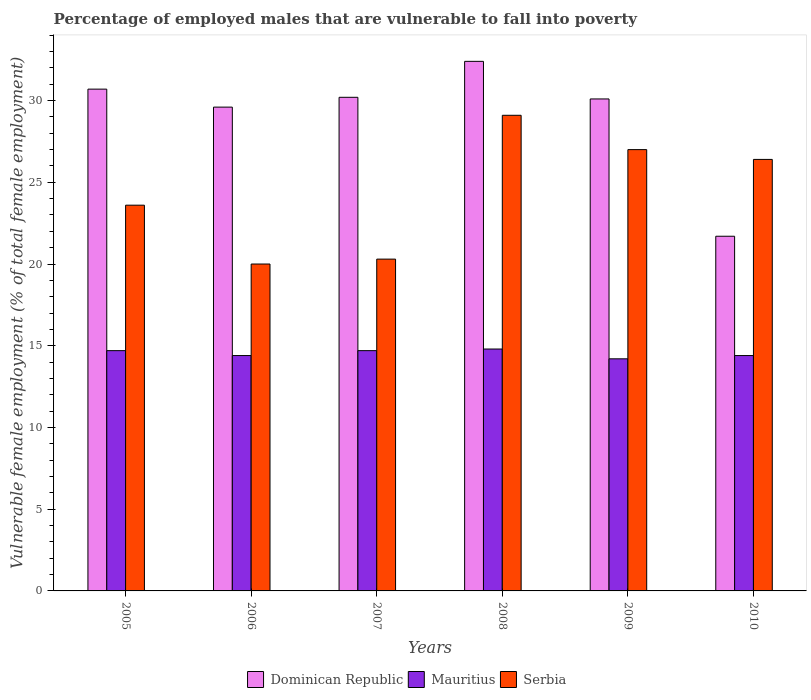How many groups of bars are there?
Provide a short and direct response. 6. Are the number of bars on each tick of the X-axis equal?
Give a very brief answer. Yes. How many bars are there on the 3rd tick from the right?
Give a very brief answer. 3. In how many cases, is the number of bars for a given year not equal to the number of legend labels?
Your answer should be compact. 0. What is the percentage of employed males who are vulnerable to fall into poverty in Mauritius in 2008?
Keep it short and to the point. 14.8. Across all years, what is the maximum percentage of employed males who are vulnerable to fall into poverty in Mauritius?
Provide a succinct answer. 14.8. Across all years, what is the minimum percentage of employed males who are vulnerable to fall into poverty in Mauritius?
Give a very brief answer. 14.2. What is the total percentage of employed males who are vulnerable to fall into poverty in Dominican Republic in the graph?
Keep it short and to the point. 174.7. What is the difference between the percentage of employed males who are vulnerable to fall into poverty in Mauritius in 2006 and that in 2008?
Offer a very short reply. -0.4. What is the difference between the percentage of employed males who are vulnerable to fall into poverty in Serbia in 2007 and the percentage of employed males who are vulnerable to fall into poverty in Mauritius in 2006?
Ensure brevity in your answer.  5.9. What is the average percentage of employed males who are vulnerable to fall into poverty in Dominican Republic per year?
Make the answer very short. 29.12. In the year 2008, what is the difference between the percentage of employed males who are vulnerable to fall into poverty in Serbia and percentage of employed males who are vulnerable to fall into poverty in Dominican Republic?
Your response must be concise. -3.3. In how many years, is the percentage of employed males who are vulnerable to fall into poverty in Mauritius greater than 2 %?
Keep it short and to the point. 6. What is the ratio of the percentage of employed males who are vulnerable to fall into poverty in Serbia in 2005 to that in 2008?
Offer a terse response. 0.81. What is the difference between the highest and the second highest percentage of employed males who are vulnerable to fall into poverty in Serbia?
Offer a very short reply. 2.1. What is the difference between the highest and the lowest percentage of employed males who are vulnerable to fall into poverty in Mauritius?
Provide a short and direct response. 0.6. What does the 1st bar from the left in 2008 represents?
Make the answer very short. Dominican Republic. What does the 3rd bar from the right in 2009 represents?
Your answer should be very brief. Dominican Republic. Is it the case that in every year, the sum of the percentage of employed males who are vulnerable to fall into poverty in Dominican Republic and percentage of employed males who are vulnerable to fall into poverty in Serbia is greater than the percentage of employed males who are vulnerable to fall into poverty in Mauritius?
Provide a short and direct response. Yes. How many bars are there?
Make the answer very short. 18. What is the difference between two consecutive major ticks on the Y-axis?
Offer a terse response. 5. Where does the legend appear in the graph?
Offer a terse response. Bottom center. How many legend labels are there?
Keep it short and to the point. 3. How are the legend labels stacked?
Your answer should be compact. Horizontal. What is the title of the graph?
Give a very brief answer. Percentage of employed males that are vulnerable to fall into poverty. Does "India" appear as one of the legend labels in the graph?
Give a very brief answer. No. What is the label or title of the Y-axis?
Your answer should be very brief. Vulnerable female employment (% of total female employment). What is the Vulnerable female employment (% of total female employment) of Dominican Republic in 2005?
Give a very brief answer. 30.7. What is the Vulnerable female employment (% of total female employment) of Mauritius in 2005?
Keep it short and to the point. 14.7. What is the Vulnerable female employment (% of total female employment) of Serbia in 2005?
Your response must be concise. 23.6. What is the Vulnerable female employment (% of total female employment) of Dominican Republic in 2006?
Your answer should be very brief. 29.6. What is the Vulnerable female employment (% of total female employment) of Mauritius in 2006?
Ensure brevity in your answer.  14.4. What is the Vulnerable female employment (% of total female employment) of Serbia in 2006?
Provide a short and direct response. 20. What is the Vulnerable female employment (% of total female employment) of Dominican Republic in 2007?
Provide a succinct answer. 30.2. What is the Vulnerable female employment (% of total female employment) of Mauritius in 2007?
Your answer should be compact. 14.7. What is the Vulnerable female employment (% of total female employment) in Serbia in 2007?
Your answer should be compact. 20.3. What is the Vulnerable female employment (% of total female employment) in Dominican Republic in 2008?
Provide a succinct answer. 32.4. What is the Vulnerable female employment (% of total female employment) of Mauritius in 2008?
Provide a succinct answer. 14.8. What is the Vulnerable female employment (% of total female employment) of Serbia in 2008?
Your response must be concise. 29.1. What is the Vulnerable female employment (% of total female employment) in Dominican Republic in 2009?
Your answer should be very brief. 30.1. What is the Vulnerable female employment (% of total female employment) of Mauritius in 2009?
Offer a terse response. 14.2. What is the Vulnerable female employment (% of total female employment) in Dominican Republic in 2010?
Provide a succinct answer. 21.7. What is the Vulnerable female employment (% of total female employment) in Mauritius in 2010?
Give a very brief answer. 14.4. What is the Vulnerable female employment (% of total female employment) in Serbia in 2010?
Ensure brevity in your answer.  26.4. Across all years, what is the maximum Vulnerable female employment (% of total female employment) of Dominican Republic?
Ensure brevity in your answer.  32.4. Across all years, what is the maximum Vulnerable female employment (% of total female employment) of Mauritius?
Ensure brevity in your answer.  14.8. Across all years, what is the maximum Vulnerable female employment (% of total female employment) in Serbia?
Your answer should be very brief. 29.1. Across all years, what is the minimum Vulnerable female employment (% of total female employment) in Dominican Republic?
Your answer should be very brief. 21.7. Across all years, what is the minimum Vulnerable female employment (% of total female employment) of Mauritius?
Provide a succinct answer. 14.2. Across all years, what is the minimum Vulnerable female employment (% of total female employment) of Serbia?
Make the answer very short. 20. What is the total Vulnerable female employment (% of total female employment) of Dominican Republic in the graph?
Your answer should be very brief. 174.7. What is the total Vulnerable female employment (% of total female employment) of Mauritius in the graph?
Your answer should be compact. 87.2. What is the total Vulnerable female employment (% of total female employment) of Serbia in the graph?
Ensure brevity in your answer.  146.4. What is the difference between the Vulnerable female employment (% of total female employment) in Mauritius in 2005 and that in 2006?
Offer a terse response. 0.3. What is the difference between the Vulnerable female employment (% of total female employment) of Mauritius in 2005 and that in 2007?
Provide a short and direct response. 0. What is the difference between the Vulnerable female employment (% of total female employment) in Serbia in 2005 and that in 2007?
Your response must be concise. 3.3. What is the difference between the Vulnerable female employment (% of total female employment) in Serbia in 2005 and that in 2008?
Make the answer very short. -5.5. What is the difference between the Vulnerable female employment (% of total female employment) of Dominican Republic in 2005 and that in 2009?
Ensure brevity in your answer.  0.6. What is the difference between the Vulnerable female employment (% of total female employment) of Dominican Republic in 2005 and that in 2010?
Offer a terse response. 9. What is the difference between the Vulnerable female employment (% of total female employment) of Mauritius in 2005 and that in 2010?
Give a very brief answer. 0.3. What is the difference between the Vulnerable female employment (% of total female employment) in Serbia in 2005 and that in 2010?
Your answer should be compact. -2.8. What is the difference between the Vulnerable female employment (% of total female employment) of Mauritius in 2006 and that in 2008?
Your answer should be very brief. -0.4. What is the difference between the Vulnerable female employment (% of total female employment) of Dominican Republic in 2006 and that in 2009?
Keep it short and to the point. -0.5. What is the difference between the Vulnerable female employment (% of total female employment) of Mauritius in 2006 and that in 2009?
Offer a terse response. 0.2. What is the difference between the Vulnerable female employment (% of total female employment) of Serbia in 2006 and that in 2009?
Provide a succinct answer. -7. What is the difference between the Vulnerable female employment (% of total female employment) in Dominican Republic in 2006 and that in 2010?
Provide a short and direct response. 7.9. What is the difference between the Vulnerable female employment (% of total female employment) of Mauritius in 2006 and that in 2010?
Your answer should be very brief. 0. What is the difference between the Vulnerable female employment (% of total female employment) in Serbia in 2006 and that in 2010?
Make the answer very short. -6.4. What is the difference between the Vulnerable female employment (% of total female employment) of Dominican Republic in 2007 and that in 2009?
Offer a very short reply. 0.1. What is the difference between the Vulnerable female employment (% of total female employment) in Serbia in 2007 and that in 2009?
Ensure brevity in your answer.  -6.7. What is the difference between the Vulnerable female employment (% of total female employment) of Dominican Republic in 2007 and that in 2010?
Keep it short and to the point. 8.5. What is the difference between the Vulnerable female employment (% of total female employment) in Serbia in 2007 and that in 2010?
Offer a very short reply. -6.1. What is the difference between the Vulnerable female employment (% of total female employment) of Dominican Republic in 2008 and that in 2009?
Provide a short and direct response. 2.3. What is the difference between the Vulnerable female employment (% of total female employment) in Dominican Republic in 2005 and the Vulnerable female employment (% of total female employment) in Serbia in 2006?
Offer a very short reply. 10.7. What is the difference between the Vulnerable female employment (% of total female employment) in Dominican Republic in 2005 and the Vulnerable female employment (% of total female employment) in Mauritius in 2007?
Your answer should be compact. 16. What is the difference between the Vulnerable female employment (% of total female employment) of Dominican Republic in 2005 and the Vulnerable female employment (% of total female employment) of Mauritius in 2008?
Offer a terse response. 15.9. What is the difference between the Vulnerable female employment (% of total female employment) of Mauritius in 2005 and the Vulnerable female employment (% of total female employment) of Serbia in 2008?
Offer a terse response. -14.4. What is the difference between the Vulnerable female employment (% of total female employment) in Mauritius in 2005 and the Vulnerable female employment (% of total female employment) in Serbia in 2009?
Offer a terse response. -12.3. What is the difference between the Vulnerable female employment (% of total female employment) in Dominican Republic in 2005 and the Vulnerable female employment (% of total female employment) in Mauritius in 2010?
Give a very brief answer. 16.3. What is the difference between the Vulnerable female employment (% of total female employment) of Mauritius in 2005 and the Vulnerable female employment (% of total female employment) of Serbia in 2010?
Offer a terse response. -11.7. What is the difference between the Vulnerable female employment (% of total female employment) in Dominican Republic in 2006 and the Vulnerable female employment (% of total female employment) in Mauritius in 2007?
Provide a succinct answer. 14.9. What is the difference between the Vulnerable female employment (% of total female employment) of Dominican Republic in 2006 and the Vulnerable female employment (% of total female employment) of Serbia in 2007?
Provide a succinct answer. 9.3. What is the difference between the Vulnerable female employment (% of total female employment) of Dominican Republic in 2006 and the Vulnerable female employment (% of total female employment) of Serbia in 2008?
Your response must be concise. 0.5. What is the difference between the Vulnerable female employment (% of total female employment) of Mauritius in 2006 and the Vulnerable female employment (% of total female employment) of Serbia in 2008?
Provide a succinct answer. -14.7. What is the difference between the Vulnerable female employment (% of total female employment) in Dominican Republic in 2006 and the Vulnerable female employment (% of total female employment) in Serbia in 2009?
Your answer should be very brief. 2.6. What is the difference between the Vulnerable female employment (% of total female employment) of Dominican Republic in 2006 and the Vulnerable female employment (% of total female employment) of Serbia in 2010?
Your answer should be compact. 3.2. What is the difference between the Vulnerable female employment (% of total female employment) of Mauritius in 2006 and the Vulnerable female employment (% of total female employment) of Serbia in 2010?
Your answer should be compact. -12. What is the difference between the Vulnerable female employment (% of total female employment) of Dominican Republic in 2007 and the Vulnerable female employment (% of total female employment) of Mauritius in 2008?
Your answer should be compact. 15.4. What is the difference between the Vulnerable female employment (% of total female employment) in Dominican Republic in 2007 and the Vulnerable female employment (% of total female employment) in Serbia in 2008?
Ensure brevity in your answer.  1.1. What is the difference between the Vulnerable female employment (% of total female employment) of Mauritius in 2007 and the Vulnerable female employment (% of total female employment) of Serbia in 2008?
Ensure brevity in your answer.  -14.4. What is the difference between the Vulnerable female employment (% of total female employment) in Dominican Republic in 2007 and the Vulnerable female employment (% of total female employment) in Mauritius in 2009?
Your answer should be compact. 16. What is the difference between the Vulnerable female employment (% of total female employment) of Dominican Republic in 2007 and the Vulnerable female employment (% of total female employment) of Serbia in 2009?
Offer a very short reply. 3.2. What is the difference between the Vulnerable female employment (% of total female employment) of Mauritius in 2007 and the Vulnerable female employment (% of total female employment) of Serbia in 2009?
Your answer should be compact. -12.3. What is the difference between the Vulnerable female employment (% of total female employment) in Dominican Republic in 2008 and the Vulnerable female employment (% of total female employment) in Mauritius in 2009?
Your answer should be very brief. 18.2. What is the difference between the Vulnerable female employment (% of total female employment) of Mauritius in 2008 and the Vulnerable female employment (% of total female employment) of Serbia in 2009?
Provide a short and direct response. -12.2. What is the difference between the Vulnerable female employment (% of total female employment) of Dominican Republic in 2008 and the Vulnerable female employment (% of total female employment) of Serbia in 2010?
Offer a terse response. 6. What is the difference between the Vulnerable female employment (% of total female employment) of Mauritius in 2008 and the Vulnerable female employment (% of total female employment) of Serbia in 2010?
Keep it short and to the point. -11.6. What is the difference between the Vulnerable female employment (% of total female employment) of Dominican Republic in 2009 and the Vulnerable female employment (% of total female employment) of Mauritius in 2010?
Keep it short and to the point. 15.7. What is the difference between the Vulnerable female employment (% of total female employment) of Dominican Republic in 2009 and the Vulnerable female employment (% of total female employment) of Serbia in 2010?
Offer a very short reply. 3.7. What is the average Vulnerable female employment (% of total female employment) in Dominican Republic per year?
Ensure brevity in your answer.  29.12. What is the average Vulnerable female employment (% of total female employment) in Mauritius per year?
Keep it short and to the point. 14.53. What is the average Vulnerable female employment (% of total female employment) of Serbia per year?
Your answer should be compact. 24.4. In the year 2005, what is the difference between the Vulnerable female employment (% of total female employment) of Dominican Republic and Vulnerable female employment (% of total female employment) of Mauritius?
Your answer should be compact. 16. In the year 2005, what is the difference between the Vulnerable female employment (% of total female employment) in Dominican Republic and Vulnerable female employment (% of total female employment) in Serbia?
Offer a terse response. 7.1. In the year 2006, what is the difference between the Vulnerable female employment (% of total female employment) of Dominican Republic and Vulnerable female employment (% of total female employment) of Serbia?
Offer a very short reply. 9.6. In the year 2007, what is the difference between the Vulnerable female employment (% of total female employment) in Dominican Republic and Vulnerable female employment (% of total female employment) in Mauritius?
Your answer should be very brief. 15.5. In the year 2008, what is the difference between the Vulnerable female employment (% of total female employment) of Dominican Republic and Vulnerable female employment (% of total female employment) of Mauritius?
Provide a short and direct response. 17.6. In the year 2008, what is the difference between the Vulnerable female employment (% of total female employment) in Dominican Republic and Vulnerable female employment (% of total female employment) in Serbia?
Offer a terse response. 3.3. In the year 2008, what is the difference between the Vulnerable female employment (% of total female employment) of Mauritius and Vulnerable female employment (% of total female employment) of Serbia?
Make the answer very short. -14.3. In the year 2010, what is the difference between the Vulnerable female employment (% of total female employment) of Dominican Republic and Vulnerable female employment (% of total female employment) of Mauritius?
Your response must be concise. 7.3. What is the ratio of the Vulnerable female employment (% of total female employment) of Dominican Republic in 2005 to that in 2006?
Provide a succinct answer. 1.04. What is the ratio of the Vulnerable female employment (% of total female employment) in Mauritius in 2005 to that in 2006?
Provide a short and direct response. 1.02. What is the ratio of the Vulnerable female employment (% of total female employment) in Serbia in 2005 to that in 2006?
Offer a very short reply. 1.18. What is the ratio of the Vulnerable female employment (% of total female employment) of Dominican Republic in 2005 to that in 2007?
Ensure brevity in your answer.  1.02. What is the ratio of the Vulnerable female employment (% of total female employment) in Serbia in 2005 to that in 2007?
Your response must be concise. 1.16. What is the ratio of the Vulnerable female employment (% of total female employment) in Dominican Republic in 2005 to that in 2008?
Give a very brief answer. 0.95. What is the ratio of the Vulnerable female employment (% of total female employment) in Mauritius in 2005 to that in 2008?
Your answer should be very brief. 0.99. What is the ratio of the Vulnerable female employment (% of total female employment) in Serbia in 2005 to that in 2008?
Keep it short and to the point. 0.81. What is the ratio of the Vulnerable female employment (% of total female employment) of Dominican Republic in 2005 to that in 2009?
Offer a very short reply. 1.02. What is the ratio of the Vulnerable female employment (% of total female employment) in Mauritius in 2005 to that in 2009?
Ensure brevity in your answer.  1.04. What is the ratio of the Vulnerable female employment (% of total female employment) of Serbia in 2005 to that in 2009?
Provide a succinct answer. 0.87. What is the ratio of the Vulnerable female employment (% of total female employment) in Dominican Republic in 2005 to that in 2010?
Your answer should be very brief. 1.41. What is the ratio of the Vulnerable female employment (% of total female employment) in Mauritius in 2005 to that in 2010?
Give a very brief answer. 1.02. What is the ratio of the Vulnerable female employment (% of total female employment) of Serbia in 2005 to that in 2010?
Your answer should be compact. 0.89. What is the ratio of the Vulnerable female employment (% of total female employment) in Dominican Republic in 2006 to that in 2007?
Make the answer very short. 0.98. What is the ratio of the Vulnerable female employment (% of total female employment) of Mauritius in 2006 to that in 2007?
Offer a very short reply. 0.98. What is the ratio of the Vulnerable female employment (% of total female employment) in Serbia in 2006 to that in 2007?
Provide a short and direct response. 0.99. What is the ratio of the Vulnerable female employment (% of total female employment) of Dominican Republic in 2006 to that in 2008?
Your response must be concise. 0.91. What is the ratio of the Vulnerable female employment (% of total female employment) in Mauritius in 2006 to that in 2008?
Provide a succinct answer. 0.97. What is the ratio of the Vulnerable female employment (% of total female employment) of Serbia in 2006 to that in 2008?
Give a very brief answer. 0.69. What is the ratio of the Vulnerable female employment (% of total female employment) of Dominican Republic in 2006 to that in 2009?
Provide a short and direct response. 0.98. What is the ratio of the Vulnerable female employment (% of total female employment) of Mauritius in 2006 to that in 2009?
Ensure brevity in your answer.  1.01. What is the ratio of the Vulnerable female employment (% of total female employment) in Serbia in 2006 to that in 2009?
Your answer should be compact. 0.74. What is the ratio of the Vulnerable female employment (% of total female employment) of Dominican Republic in 2006 to that in 2010?
Offer a very short reply. 1.36. What is the ratio of the Vulnerable female employment (% of total female employment) in Mauritius in 2006 to that in 2010?
Provide a succinct answer. 1. What is the ratio of the Vulnerable female employment (% of total female employment) of Serbia in 2006 to that in 2010?
Offer a terse response. 0.76. What is the ratio of the Vulnerable female employment (% of total female employment) of Dominican Republic in 2007 to that in 2008?
Make the answer very short. 0.93. What is the ratio of the Vulnerable female employment (% of total female employment) of Mauritius in 2007 to that in 2008?
Your response must be concise. 0.99. What is the ratio of the Vulnerable female employment (% of total female employment) in Serbia in 2007 to that in 2008?
Provide a succinct answer. 0.7. What is the ratio of the Vulnerable female employment (% of total female employment) in Dominican Republic in 2007 to that in 2009?
Your answer should be compact. 1. What is the ratio of the Vulnerable female employment (% of total female employment) of Mauritius in 2007 to that in 2009?
Make the answer very short. 1.04. What is the ratio of the Vulnerable female employment (% of total female employment) of Serbia in 2007 to that in 2009?
Keep it short and to the point. 0.75. What is the ratio of the Vulnerable female employment (% of total female employment) of Dominican Republic in 2007 to that in 2010?
Give a very brief answer. 1.39. What is the ratio of the Vulnerable female employment (% of total female employment) of Mauritius in 2007 to that in 2010?
Provide a short and direct response. 1.02. What is the ratio of the Vulnerable female employment (% of total female employment) in Serbia in 2007 to that in 2010?
Give a very brief answer. 0.77. What is the ratio of the Vulnerable female employment (% of total female employment) of Dominican Republic in 2008 to that in 2009?
Keep it short and to the point. 1.08. What is the ratio of the Vulnerable female employment (% of total female employment) in Mauritius in 2008 to that in 2009?
Provide a short and direct response. 1.04. What is the ratio of the Vulnerable female employment (% of total female employment) in Serbia in 2008 to that in 2009?
Make the answer very short. 1.08. What is the ratio of the Vulnerable female employment (% of total female employment) in Dominican Republic in 2008 to that in 2010?
Offer a very short reply. 1.49. What is the ratio of the Vulnerable female employment (% of total female employment) of Mauritius in 2008 to that in 2010?
Ensure brevity in your answer.  1.03. What is the ratio of the Vulnerable female employment (% of total female employment) in Serbia in 2008 to that in 2010?
Your answer should be compact. 1.1. What is the ratio of the Vulnerable female employment (% of total female employment) in Dominican Republic in 2009 to that in 2010?
Your answer should be compact. 1.39. What is the ratio of the Vulnerable female employment (% of total female employment) in Mauritius in 2009 to that in 2010?
Offer a terse response. 0.99. What is the ratio of the Vulnerable female employment (% of total female employment) of Serbia in 2009 to that in 2010?
Give a very brief answer. 1.02. What is the difference between the highest and the second highest Vulnerable female employment (% of total female employment) of Dominican Republic?
Ensure brevity in your answer.  1.7. What is the difference between the highest and the second highest Vulnerable female employment (% of total female employment) of Mauritius?
Your answer should be compact. 0.1. What is the difference between the highest and the lowest Vulnerable female employment (% of total female employment) of Dominican Republic?
Provide a short and direct response. 10.7. 